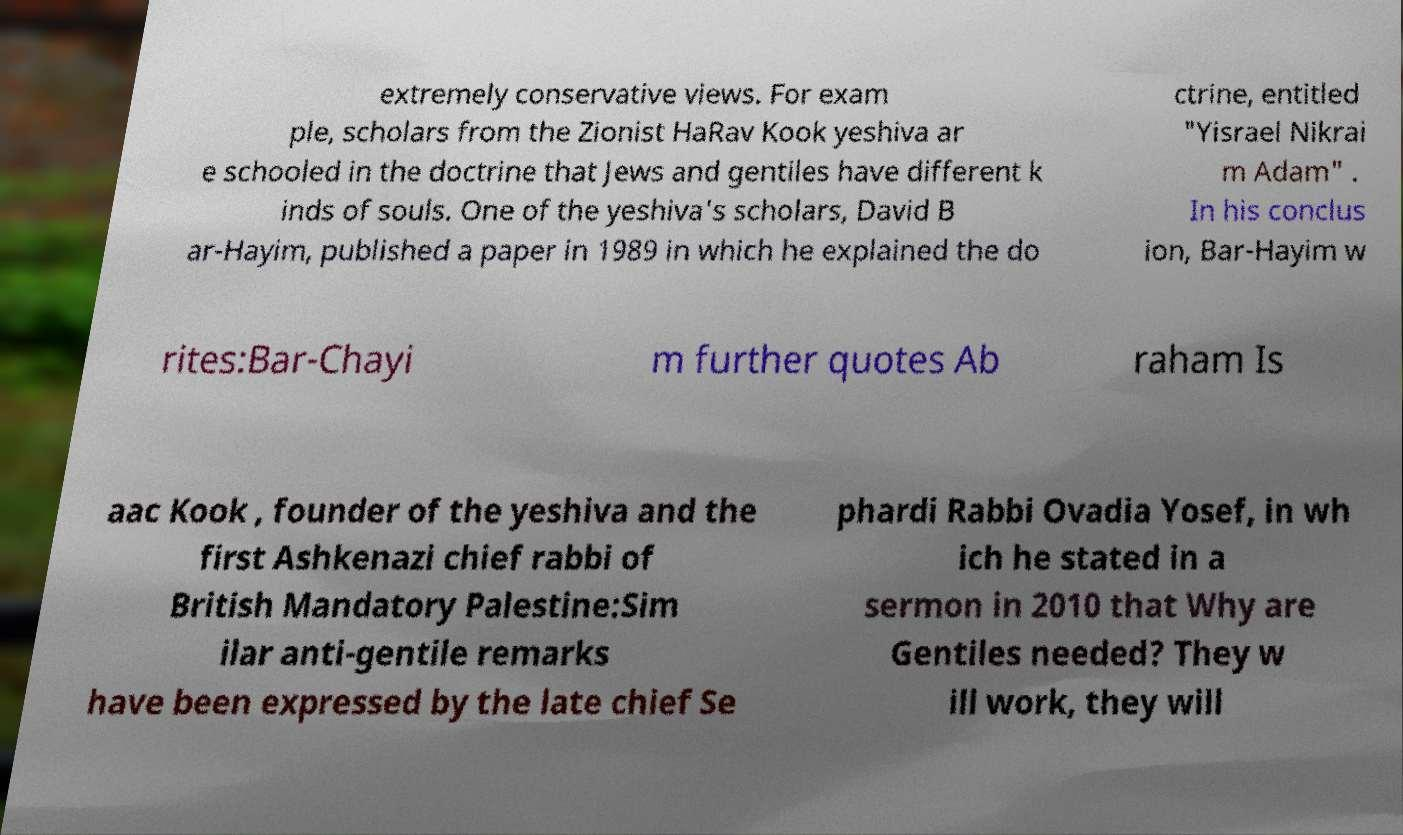There's text embedded in this image that I need extracted. Can you transcribe it verbatim? extremely conservative views. For exam ple, scholars from the Zionist HaRav Kook yeshiva ar e schooled in the doctrine that Jews and gentiles have different k inds of souls. One of the yeshiva's scholars, David B ar-Hayim, published a paper in 1989 in which he explained the do ctrine, entitled "Yisrael Nikrai m Adam" . In his conclus ion, Bar-Hayim w rites:Bar-Chayi m further quotes Ab raham Is aac Kook , founder of the yeshiva and the first Ashkenazi chief rabbi of British Mandatory Palestine:Sim ilar anti-gentile remarks have been expressed by the late chief Se phardi Rabbi Ovadia Yosef, in wh ich he stated in a sermon in 2010 that Why are Gentiles needed? They w ill work, they will 